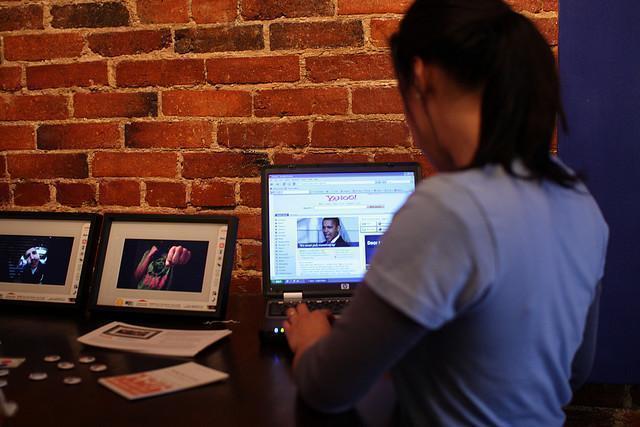In what year did the website on her screen become a company?
Select the accurate response from the four choices given to answer the question.
Options: 1999, 1994, 1998, 2003. 1994. 